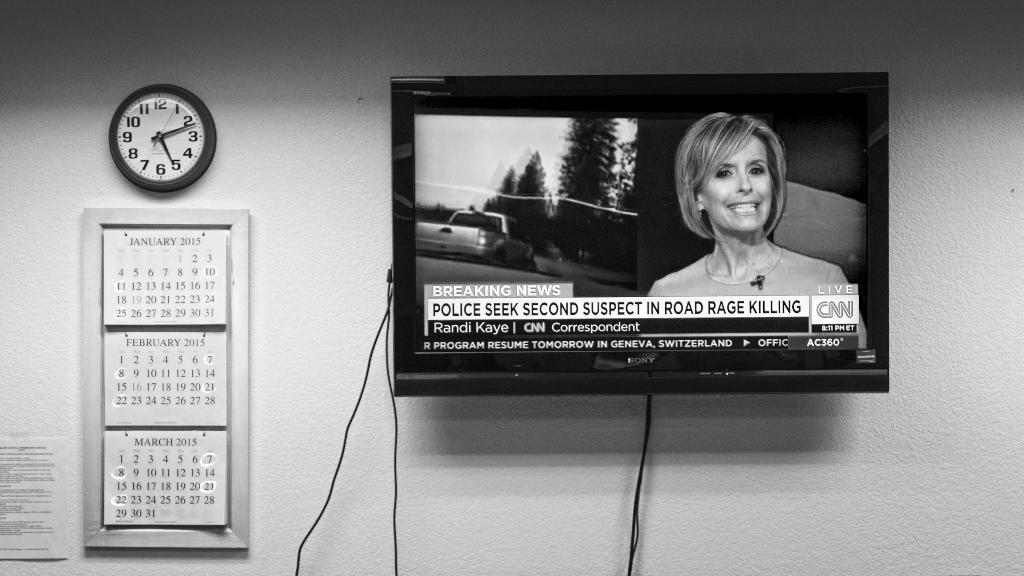Provide a one-sentence caption for the provided image. The televisiion is turned to the CNN channel. 